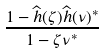Convert formula to latex. <formula><loc_0><loc_0><loc_500><loc_500>\frac { 1 - \widehat { h } ( \zeta ) \widehat { h } ( \nu ) ^ { * } } { 1 - \zeta \nu ^ { * } }</formula> 